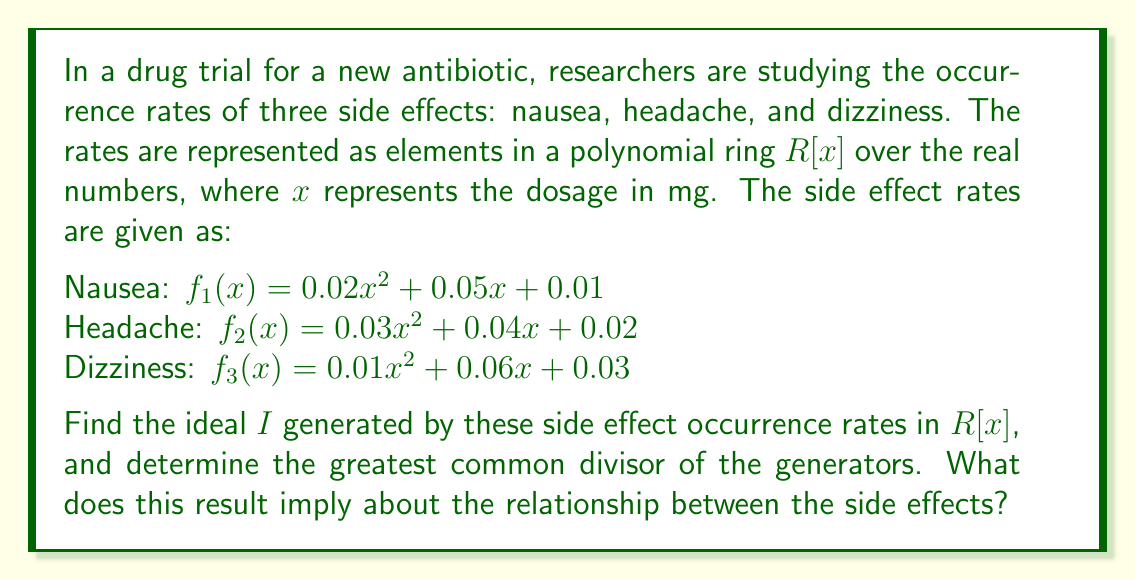Could you help me with this problem? To solve this problem, we need to follow these steps:

1) The ideal $I$ generated by the side effect occurrence rates is:

   $I = \langle f_1(x), f_2(x), f_3(x) \rangle$

2) To find the greatest common divisor (GCD) of these polynomials, we first need to factor them:

   $f_1(x) = 0.01(2x^2 + 5x + 1)$
   $f_2(x) = 0.01(3x^2 + 4x + 2)$
   $f_3(x) = 0.01(x^2 + 6x + 3)$

3) We can factor out the common factor of 0.01:

   $I = 0.01\langle 2x^2 + 5x + 1, 3x^2 + 4x + 2, x^2 + 6x + 3 \rangle$

4) Now, we need to find the GCD of $2x^2 + 5x + 1$, $3x^2 + 4x + 2$, and $x^2 + 6x + 3$. We can use the Euclidean algorithm for polynomials:

   First, divide $2x^2 + 5x + 1$ by $x^2 + 6x + 3$:
   $2x^2 + 5x + 1 = 2(x^2 + 6x + 3) - (7x + 5)$

   Next, divide $x^2 + 6x + 3$ by $7x + 5$:
   $x^2 + 6x + 3 = \frac{1}{7}(7x + 5)(x - 1) + \frac{22}{7}$

   The remainder is a constant, so the GCD is 1.

5) Therefore, the ideal $I$ can be simplified to:

   $I = 0.01\langle 1 \rangle = \langle 0.01 \rangle$

This means that any polynomial in the ideal $I$ is a multiple of 0.01.
Answer: The ideal generated by the side effect occurrence rates is $I = \langle 0.01 \rangle$. The greatest common divisor of the generators is 0.01. This implies that the side effects are linearly independent, meaning that the occurrence of one side effect does not directly predict the occurrence of another. However, they all share a common scaling factor of 0.01, which might represent a baseline risk or measurement unit in the study. 